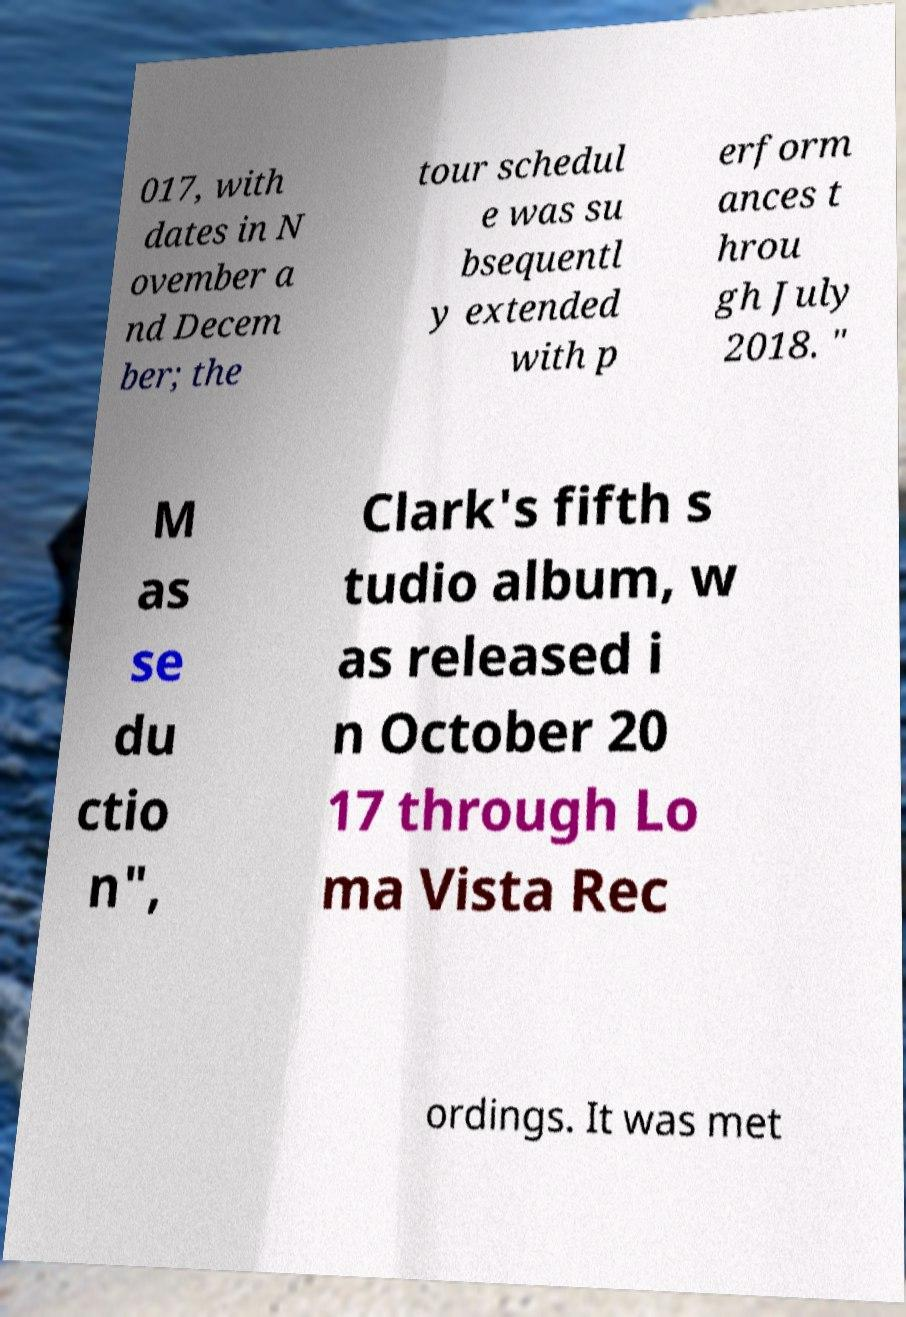There's text embedded in this image that I need extracted. Can you transcribe it verbatim? 017, with dates in N ovember a nd Decem ber; the tour schedul e was su bsequentl y extended with p erform ances t hrou gh July 2018. " M as se du ctio n", Clark's fifth s tudio album, w as released i n October 20 17 through Lo ma Vista Rec ordings. It was met 